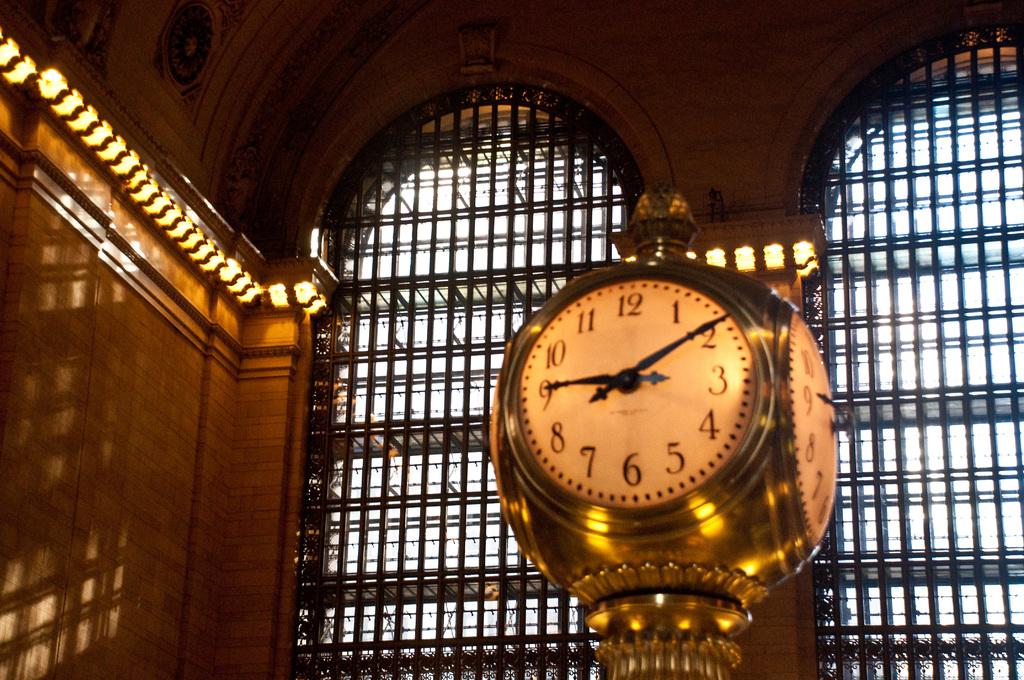What time is it?
Make the answer very short. 9:10. 